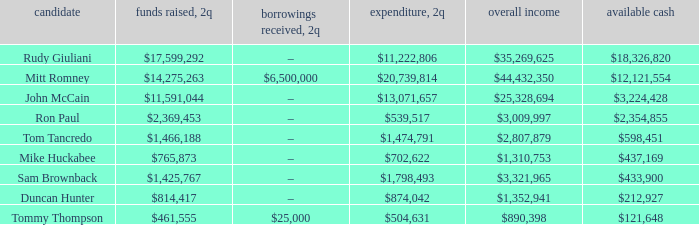Name the loans received for 2Q having total receipts of $25,328,694 –. 